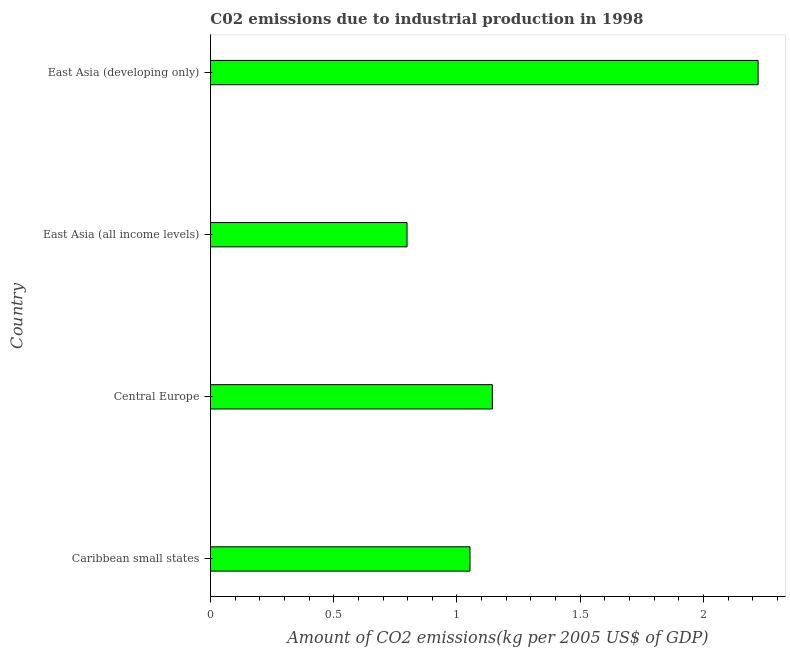Does the graph contain any zero values?
Your response must be concise. No. What is the title of the graph?
Make the answer very short. C02 emissions due to industrial production in 1998. What is the label or title of the X-axis?
Offer a terse response. Amount of CO2 emissions(kg per 2005 US$ of GDP). What is the label or title of the Y-axis?
Ensure brevity in your answer.  Country. What is the amount of co2 emissions in Caribbean small states?
Offer a very short reply. 1.05. Across all countries, what is the maximum amount of co2 emissions?
Ensure brevity in your answer.  2.22. Across all countries, what is the minimum amount of co2 emissions?
Your answer should be very brief. 0.8. In which country was the amount of co2 emissions maximum?
Ensure brevity in your answer.  East Asia (developing only). In which country was the amount of co2 emissions minimum?
Keep it short and to the point. East Asia (all income levels). What is the sum of the amount of co2 emissions?
Provide a short and direct response. 5.22. What is the difference between the amount of co2 emissions in Caribbean small states and Central Europe?
Your answer should be compact. -0.09. What is the average amount of co2 emissions per country?
Ensure brevity in your answer.  1.3. What is the median amount of co2 emissions?
Your answer should be compact. 1.1. In how many countries, is the amount of co2 emissions greater than 2.1 kg per 2005 US$ of GDP?
Keep it short and to the point. 1. What is the ratio of the amount of co2 emissions in Caribbean small states to that in East Asia (all income levels)?
Ensure brevity in your answer.  1.32. Is the amount of co2 emissions in Central Europe less than that in East Asia (developing only)?
Provide a succinct answer. Yes. Is the difference between the amount of co2 emissions in Central Europe and East Asia (all income levels) greater than the difference between any two countries?
Your answer should be very brief. No. What is the difference between the highest and the second highest amount of co2 emissions?
Your answer should be very brief. 1.08. What is the difference between the highest and the lowest amount of co2 emissions?
Keep it short and to the point. 1.42. In how many countries, is the amount of co2 emissions greater than the average amount of co2 emissions taken over all countries?
Provide a short and direct response. 1. How many bars are there?
Offer a terse response. 4. Are all the bars in the graph horizontal?
Your answer should be very brief. Yes. What is the difference between two consecutive major ticks on the X-axis?
Make the answer very short. 0.5. What is the Amount of CO2 emissions(kg per 2005 US$ of GDP) of Caribbean small states?
Provide a short and direct response. 1.05. What is the Amount of CO2 emissions(kg per 2005 US$ of GDP) of Central Europe?
Your response must be concise. 1.14. What is the Amount of CO2 emissions(kg per 2005 US$ of GDP) in East Asia (all income levels)?
Keep it short and to the point. 0.8. What is the Amount of CO2 emissions(kg per 2005 US$ of GDP) of East Asia (developing only)?
Keep it short and to the point. 2.22. What is the difference between the Amount of CO2 emissions(kg per 2005 US$ of GDP) in Caribbean small states and Central Europe?
Keep it short and to the point. -0.09. What is the difference between the Amount of CO2 emissions(kg per 2005 US$ of GDP) in Caribbean small states and East Asia (all income levels)?
Offer a terse response. 0.26. What is the difference between the Amount of CO2 emissions(kg per 2005 US$ of GDP) in Caribbean small states and East Asia (developing only)?
Make the answer very short. -1.17. What is the difference between the Amount of CO2 emissions(kg per 2005 US$ of GDP) in Central Europe and East Asia (all income levels)?
Provide a short and direct response. 0.35. What is the difference between the Amount of CO2 emissions(kg per 2005 US$ of GDP) in Central Europe and East Asia (developing only)?
Give a very brief answer. -1.08. What is the difference between the Amount of CO2 emissions(kg per 2005 US$ of GDP) in East Asia (all income levels) and East Asia (developing only)?
Offer a very short reply. -1.42. What is the ratio of the Amount of CO2 emissions(kg per 2005 US$ of GDP) in Caribbean small states to that in Central Europe?
Keep it short and to the point. 0.92. What is the ratio of the Amount of CO2 emissions(kg per 2005 US$ of GDP) in Caribbean small states to that in East Asia (all income levels)?
Your answer should be compact. 1.32. What is the ratio of the Amount of CO2 emissions(kg per 2005 US$ of GDP) in Caribbean small states to that in East Asia (developing only)?
Ensure brevity in your answer.  0.47. What is the ratio of the Amount of CO2 emissions(kg per 2005 US$ of GDP) in Central Europe to that in East Asia (all income levels)?
Offer a very short reply. 1.43. What is the ratio of the Amount of CO2 emissions(kg per 2005 US$ of GDP) in Central Europe to that in East Asia (developing only)?
Ensure brevity in your answer.  0.52. What is the ratio of the Amount of CO2 emissions(kg per 2005 US$ of GDP) in East Asia (all income levels) to that in East Asia (developing only)?
Ensure brevity in your answer.  0.36. 